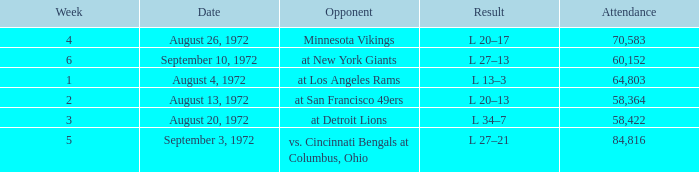What is the lowest attendance on September 3, 1972? 84816.0. 